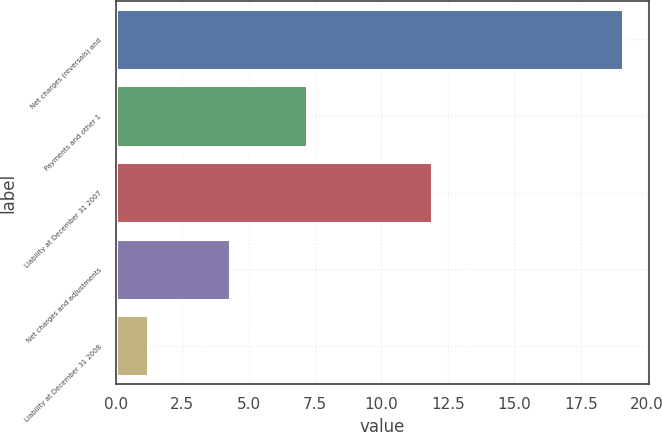<chart> <loc_0><loc_0><loc_500><loc_500><bar_chart><fcel>Net charges (reversals) and<fcel>Payments and other 1<fcel>Liability at December 31 2007<fcel>Net charges and adjustments<fcel>Liability at December 31 2008<nl><fcel>19.1<fcel>7.2<fcel>11.9<fcel>4.3<fcel>1.2<nl></chart> 